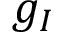<formula> <loc_0><loc_0><loc_500><loc_500>g _ { I }</formula> 